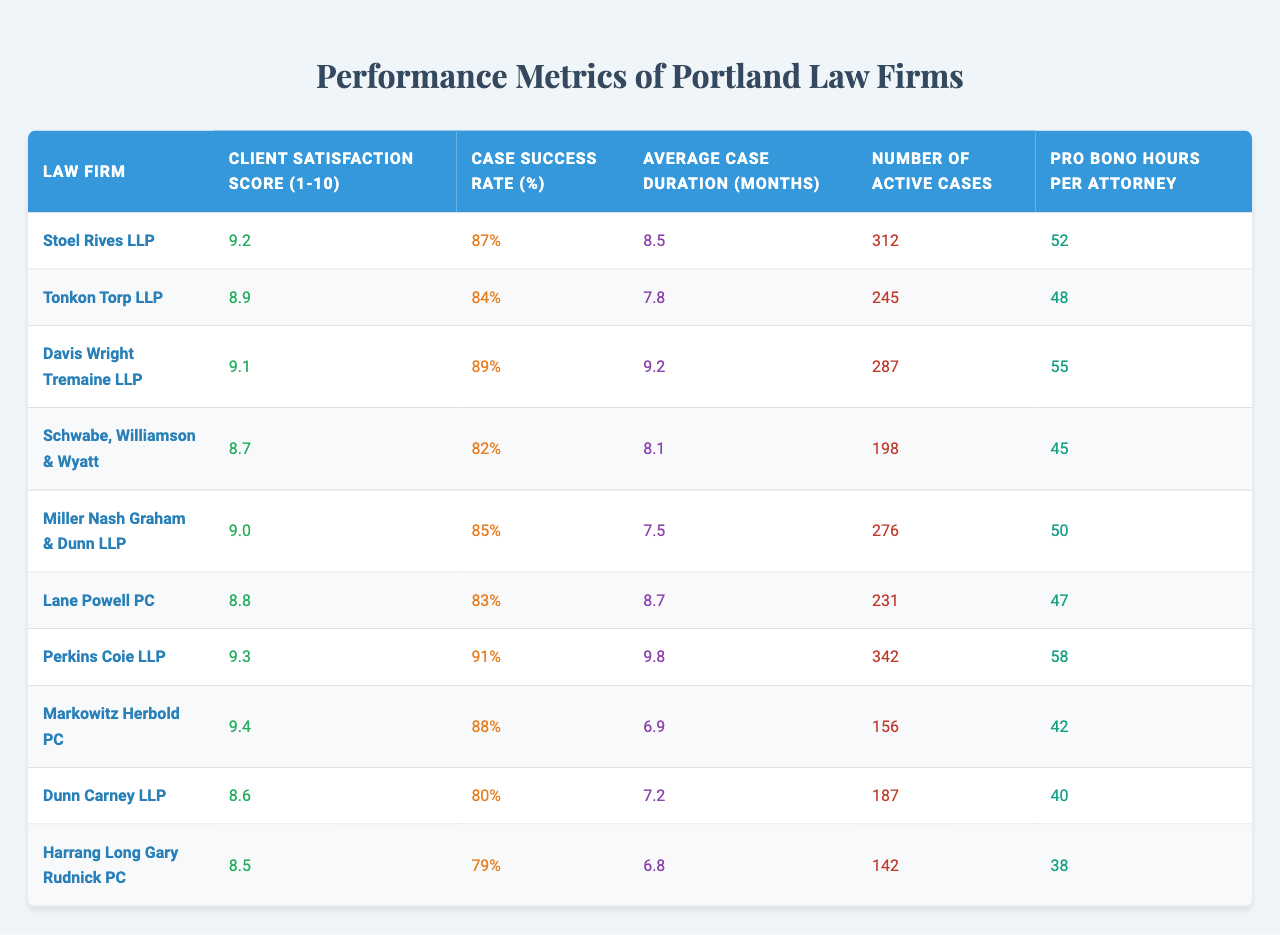What is the client satisfaction score of Perkins Coie LLP? The table shows that Perkins Coie LLP has a client satisfaction score of 9.3.
Answer: 9.3 Which law firm has the highest case success rate? Looking at the case success rate column, Perkins Coie LLP has the highest rate at 91%.
Answer: 91% What is the average case duration for Dunn Carney LLP? According to the table, Dunn Carney LLP has an average case duration of 7.2 months.
Answer: 7.2 months Is the pro bono hours per attorney for Davis Wright Tremaine LLP greater than 50? The table indicates that Davis Wright Tremaine LLP has 55 pro bono hours per attorney, which is indeed greater than 50.
Answer: Yes How many active cases does Miller Nash Graham & Dunn LLP have? The table shows that Miller Nash Graham & Dunn LLP has 276 active cases.
Answer: 276 What is the difference in client satisfaction scores between Stoel Rives LLP and Schwabe, Williamson & Wyatt? Stoel Rives LLP has a score of 9.2 while Schwabe, Williamson & Wyatt has 8.7. The difference is 9.2 - 8.7 = 0.5.
Answer: 0.5 Find the average client satisfaction score of all listed law firms. The client satisfaction scores are 9.2, 8.9, 9.1, 8.7, 9.0, 8.8, 9.3, 9.4, 8.6, 8.5. Summing these gives 88.5, and dividing by 10 yields an average score of 8.85.
Answer: 8.85 Which law firm has the lowest case success rate, and what is that rate? The table shows that Dunn Carney LLP has the lowest case success rate at 80%.
Answer: Dunn Carney LLP, 80% How many more cases does Perkins Coie LLP have compared to Harrang Long Gary Rudnick PC? Perkins Coie LLP has 342 active cases, while Harrang Long Gary Rudnick PC has 142 active cases. The difference is 342 - 142 = 200.
Answer: 200 What percentage of law firms in the table have a client satisfaction score of 9 or higher? There are 5 firms (Stoel Rives LLP, Davis Wright Tremaine LLP, Perkins Coie LLP, Markowitz Herbold PC, and Miller Nash Graham & Dunn LLP) with scores of 9 or higher out of 10 total firms, which is (5/10)*100 = 50%.
Answer: 50% 